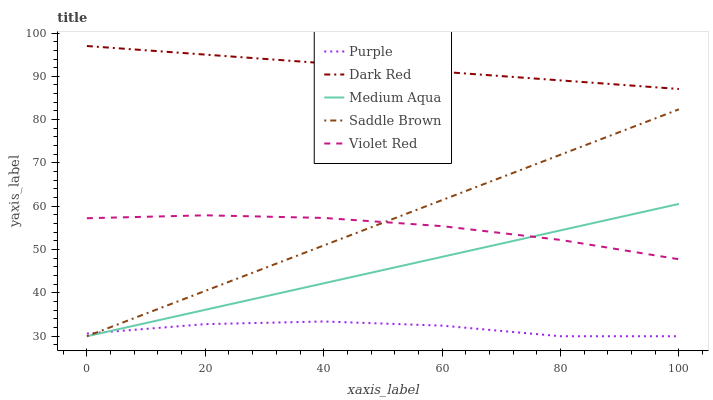Does Purple have the minimum area under the curve?
Answer yes or no. Yes. Does Dark Red have the maximum area under the curve?
Answer yes or no. Yes. Does Violet Red have the minimum area under the curve?
Answer yes or no. No. Does Violet Red have the maximum area under the curve?
Answer yes or no. No. Is Dark Red the smoothest?
Answer yes or no. Yes. Is Purple the roughest?
Answer yes or no. Yes. Is Violet Red the smoothest?
Answer yes or no. No. Is Violet Red the roughest?
Answer yes or no. No. Does Purple have the lowest value?
Answer yes or no. Yes. Does Violet Red have the lowest value?
Answer yes or no. No. Does Dark Red have the highest value?
Answer yes or no. Yes. Does Violet Red have the highest value?
Answer yes or no. No. Is Purple less than Violet Red?
Answer yes or no. Yes. Is Dark Red greater than Saddle Brown?
Answer yes or no. Yes. Does Purple intersect Saddle Brown?
Answer yes or no. Yes. Is Purple less than Saddle Brown?
Answer yes or no. No. Is Purple greater than Saddle Brown?
Answer yes or no. No. Does Purple intersect Violet Red?
Answer yes or no. No. 